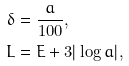Convert formula to latex. <formula><loc_0><loc_0><loc_500><loc_500>\delta & = \frac { a } { 1 0 0 } , \\ L & = E + 3 | \log a | ,</formula> 